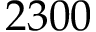Convert formula to latex. <formula><loc_0><loc_0><loc_500><loc_500>2 3 0 0</formula> 